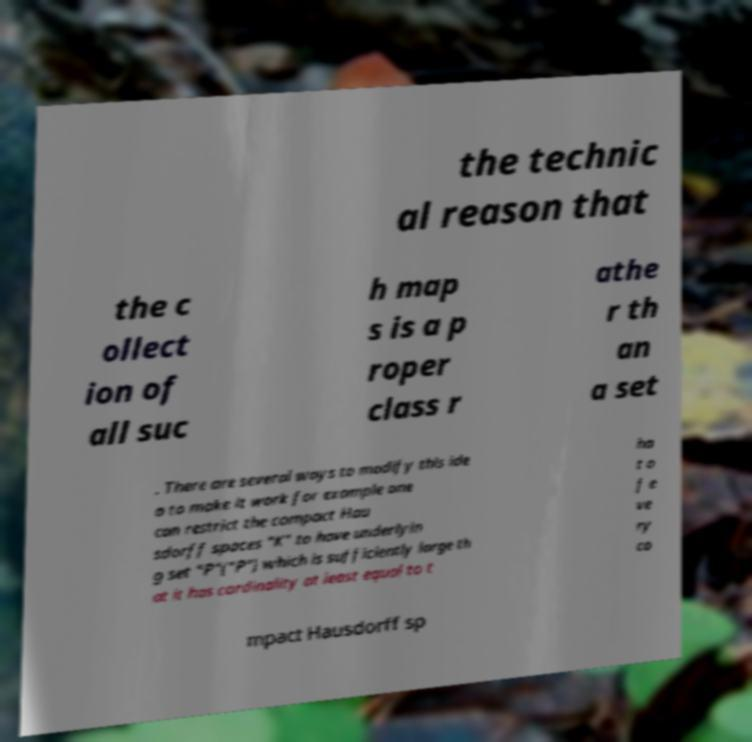What messages or text are displayed in this image? I need them in a readable, typed format. the technic al reason that the c ollect ion of all suc h map s is a p roper class r athe r th an a set . There are several ways to modify this ide a to make it work for example one can restrict the compact Hau sdorff spaces "K" to have underlyin g set "P"("P") which is sufficiently large th at it has cardinality at least equal to t ha t o f e ve ry co mpact Hausdorff sp 